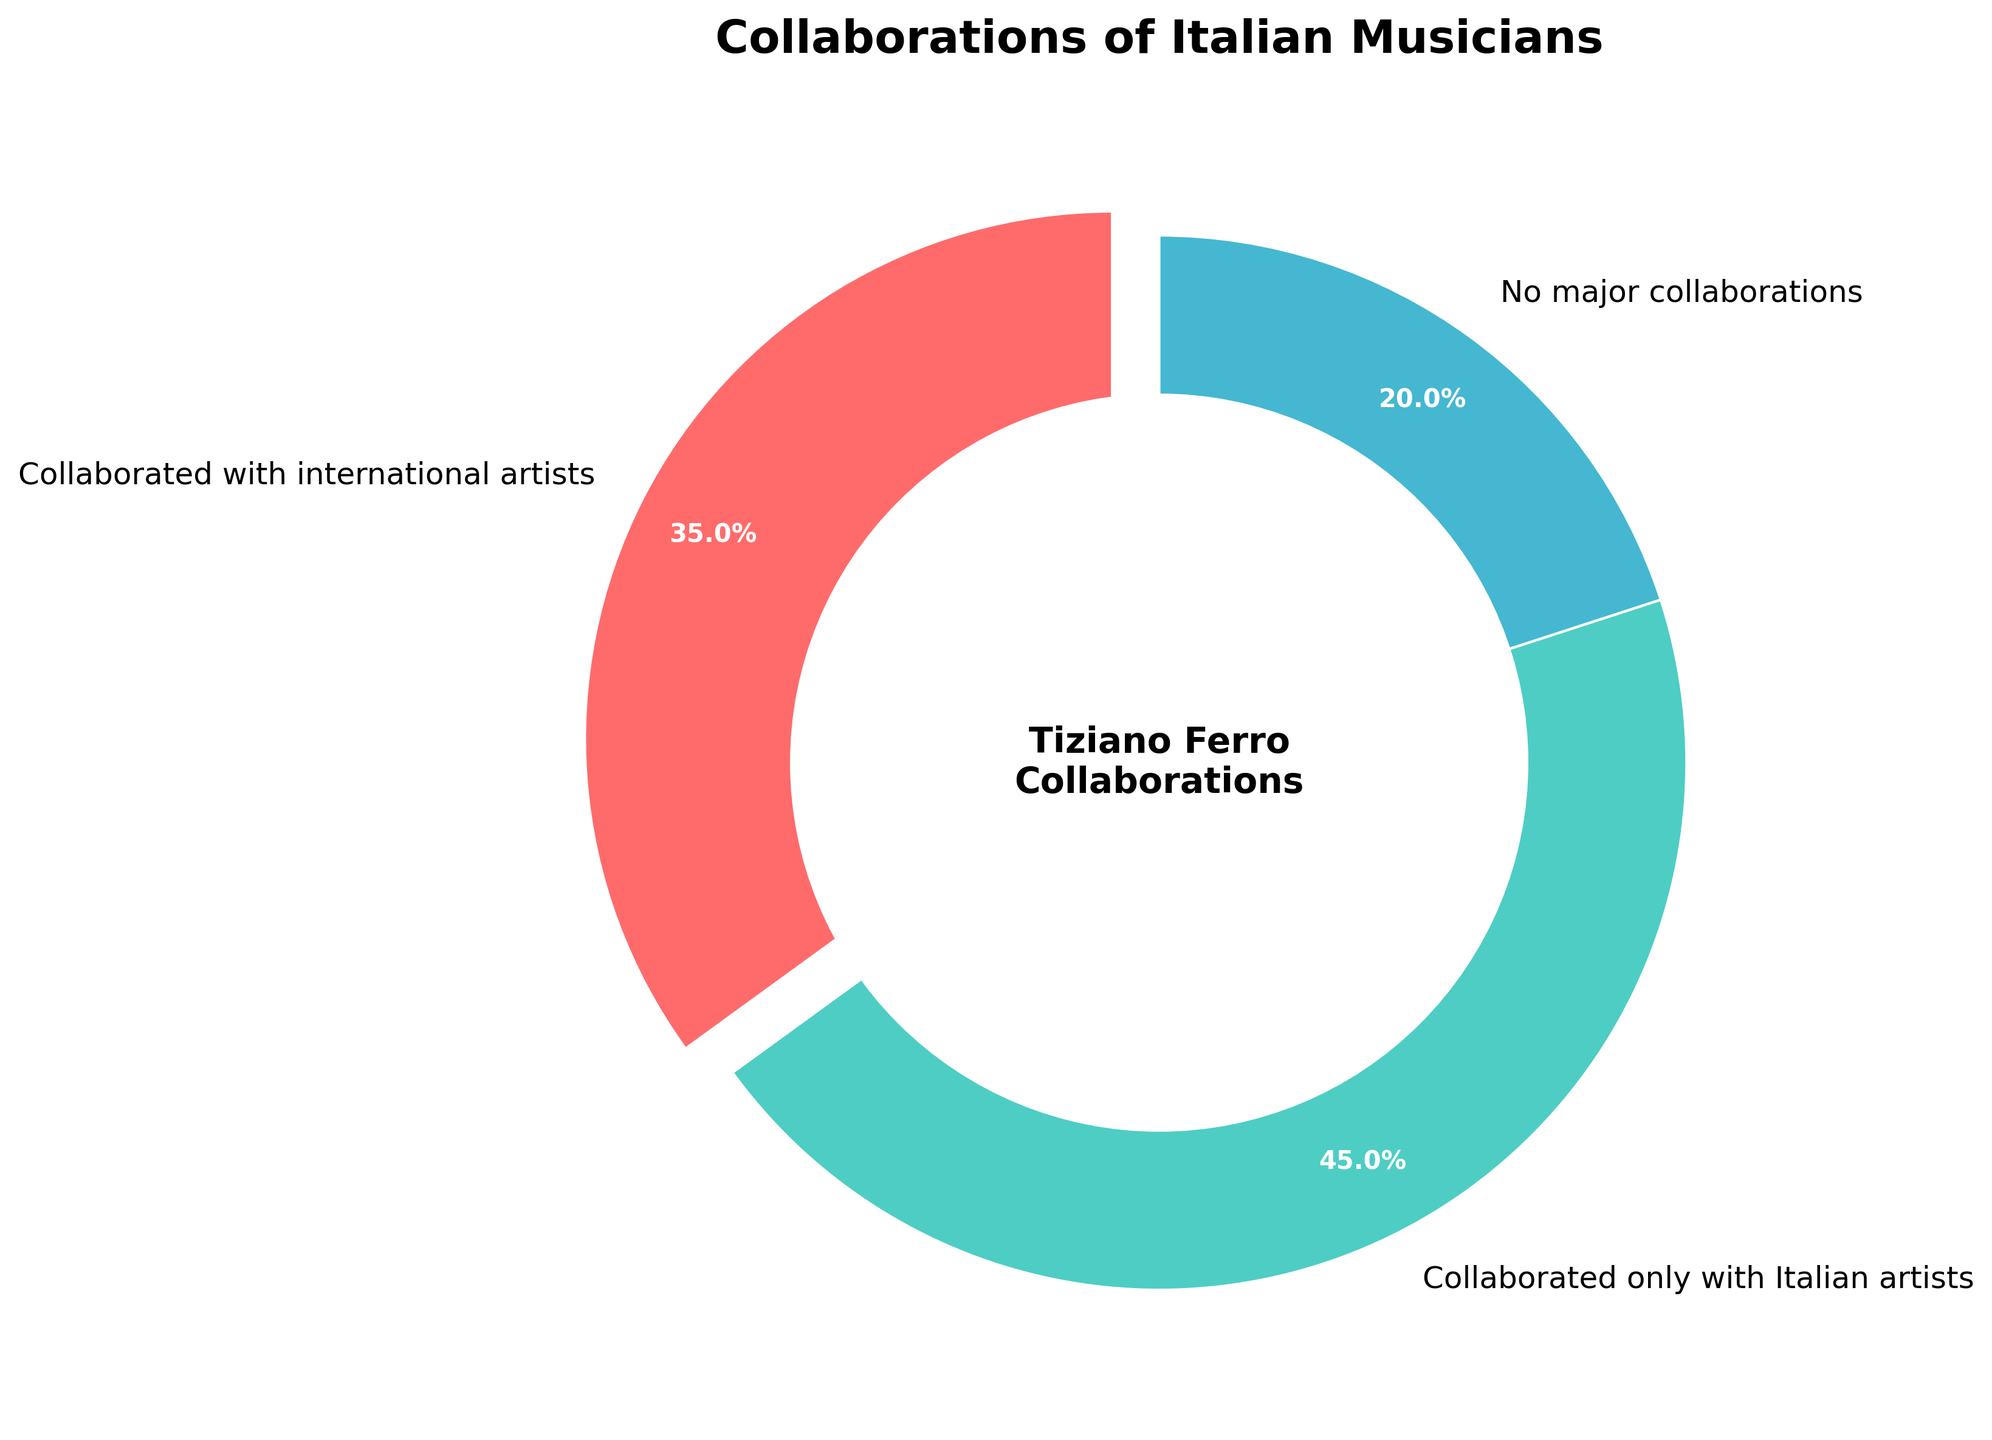Which category of collaboration has the highest percentage? By examining the slices in the pie chart, the slice labeled "Collaborated only with Italian artists" is the largest, indicating it has the highest percentage. Its proportion is represented visually as 45%.
Answer: Collaborated only with Italian artists How much greater is the percentage of musicians who collaborated only with Italian artists compared to those who had no major collaborations? The percentage of musicians who collaborated only with Italian artists is 45%, and for those with no major collaborations, it's 20%. The difference is calculated as 45% - 20% = 25%.
Answer: 25% What is the sum of the percentages of musicians who have collaborated with international artists and those with no major collaborations? The percentage for those who collaborated with international artists is 35%, and for those with no major collaborations, it's 20%. Therefore, the sum is 35% + 20% = 55%.
Answer: 55% What percentage of musicians did not collaborate with international artists? By adding the percentages of musicians who collaborated only with Italian artists (45%) and those who had no major collaborations (20%), we get the total percentage that did not collaborate with international artists: 45% + 20% = 65%.
Answer: 65% Which category is represented by the red slice in the pie chart? Observing the colors and their corresponding labels, the red slice is associated with the category "Collaborated with international artists".
Answer: Collaborated with international artists If you combine all categories, what should be the total percentage? The total sum of all categories in a pie chart must be 100% to represent the whole population. Here, the categories are 35%, 45%, and 20%, which add up to 100%.
Answer: 100% Which category has the smallest percentage? By visually comparing the slices, the smallest slice corresponds to the category labeled "No major collaborations" at 20%.
Answer: No major collaborations 